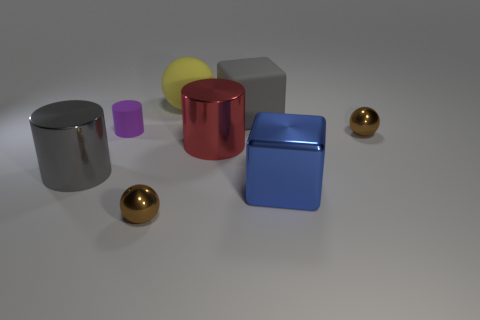What is the possible material of the objects and what does that suggest about their weight? Given their metallic sheen and reflective qualities, the objects may be made of materials such as metal or a plastic with a metallic finish. The perceived materials imply that the objects might be quite heavy if they are indeed metallic, while if they're plastic, they could be deceptively lightweight despite their appearance. 